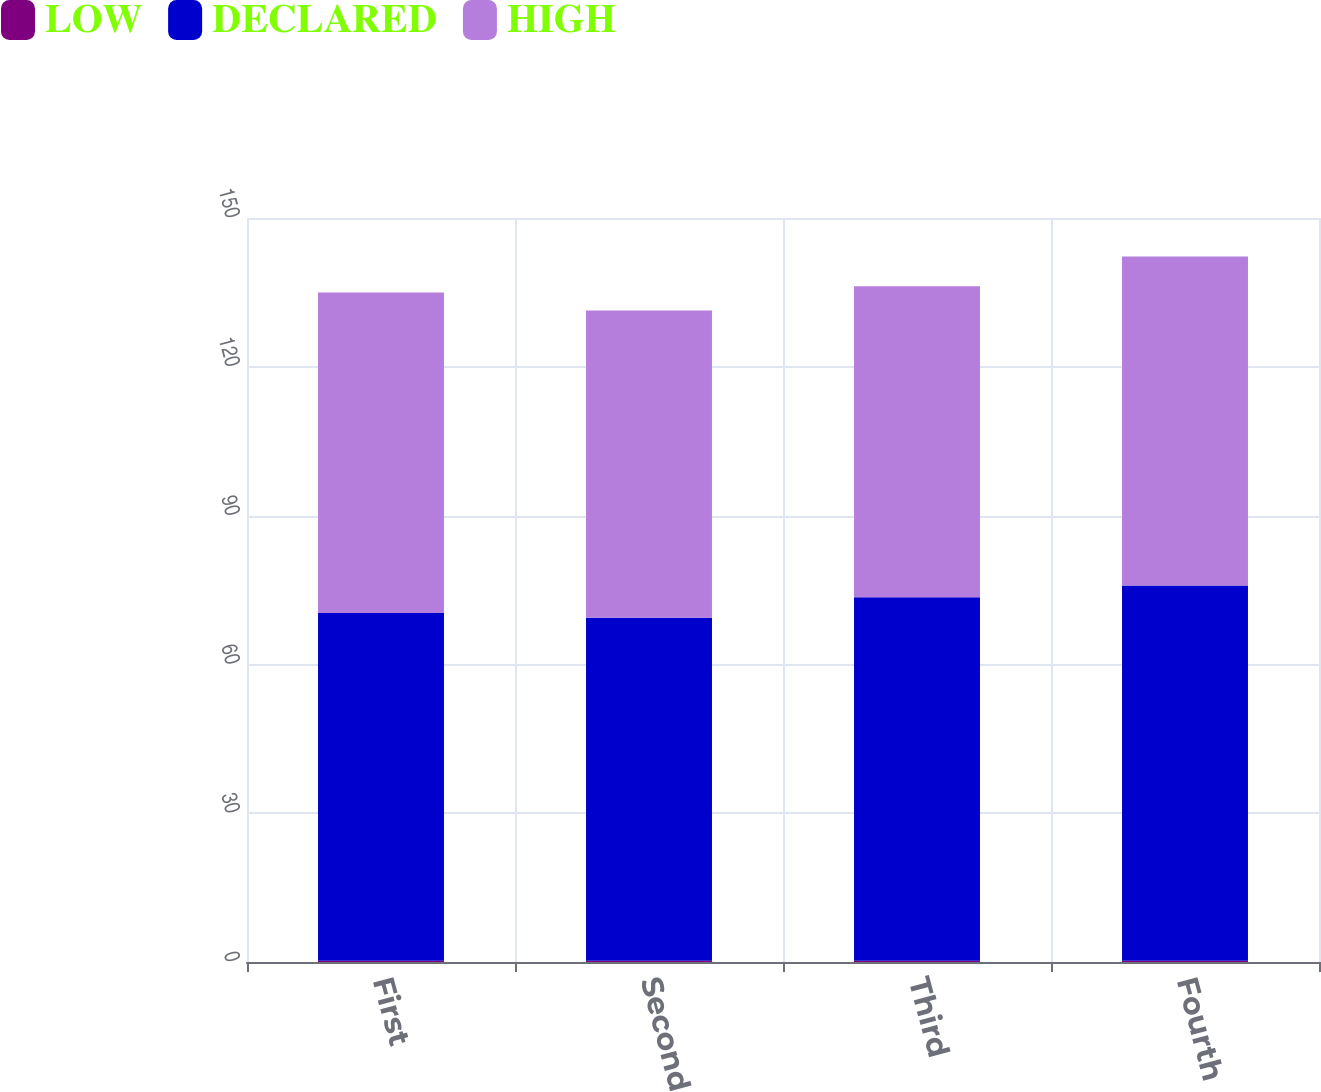<chart> <loc_0><loc_0><loc_500><loc_500><stacked_bar_chart><ecel><fcel>First<fcel>Second<fcel>Third<fcel>Fourth<nl><fcel>LOW<fcel>0.24<fcel>0.25<fcel>0.25<fcel>0.25<nl><fcel>DECLARED<fcel>70.12<fcel>69.17<fcel>73.29<fcel>75.68<nl><fcel>HIGH<fcel>64.61<fcel>61.93<fcel>62.72<fcel>66.33<nl></chart> 